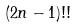<formula> <loc_0><loc_0><loc_500><loc_500>( 2 n - 1 ) ! !</formula> 